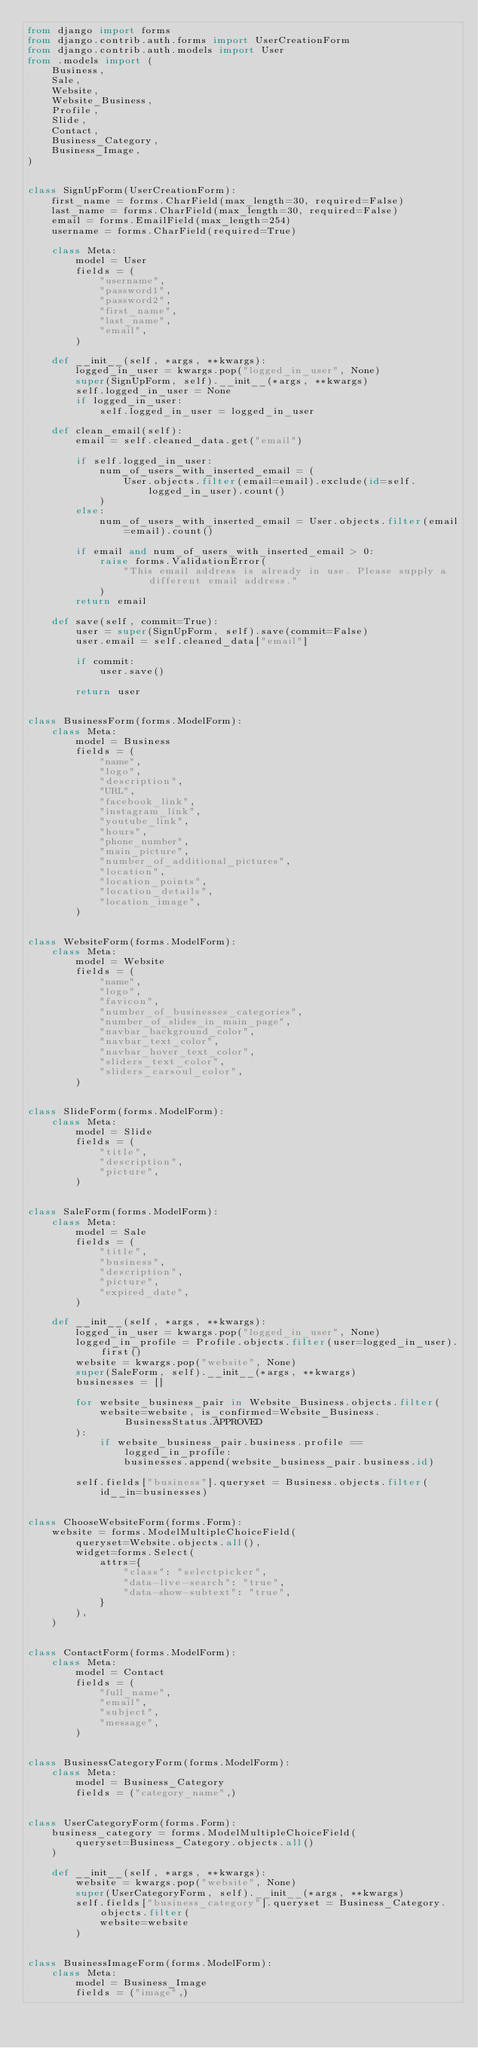<code> <loc_0><loc_0><loc_500><loc_500><_Python_>from django import forms
from django.contrib.auth.forms import UserCreationForm
from django.contrib.auth.models import User
from .models import (
    Business,
    Sale,
    Website,
    Website_Business,
    Profile,
    Slide,
    Contact,
    Business_Category,
    Business_Image,
)


class SignUpForm(UserCreationForm):
    first_name = forms.CharField(max_length=30, required=False)
    last_name = forms.CharField(max_length=30, required=False)
    email = forms.EmailField(max_length=254)
    username = forms.CharField(required=True)

    class Meta:
        model = User
        fields = (
            "username",
            "password1",
            "password2",
            "first_name",
            "last_name",
            "email",
        )

    def __init__(self, *args, **kwargs):
        logged_in_user = kwargs.pop("logged_in_user", None)
        super(SignUpForm, self).__init__(*args, **kwargs)
        self.logged_in_user = None
        if logged_in_user:
            self.logged_in_user = logged_in_user

    def clean_email(self):
        email = self.cleaned_data.get("email")

        if self.logged_in_user:
            num_of_users_with_inserted_email = (
                User.objects.filter(email=email).exclude(id=self.logged_in_user).count()
            )
        else:
            num_of_users_with_inserted_email = User.objects.filter(email=email).count()

        if email and num_of_users_with_inserted_email > 0:
            raise forms.ValidationError(
                "This email address is already in use. Please supply a different email address."
            )
        return email

    def save(self, commit=True):
        user = super(SignUpForm, self).save(commit=False)
        user.email = self.cleaned_data["email"]

        if commit:
            user.save()

        return user


class BusinessForm(forms.ModelForm):
    class Meta:
        model = Business
        fields = (
            "name",
            "logo",
            "description",
            "URL",
            "facebook_link",
            "instagram_link",
            "youtube_link",
            "hours",
            "phone_number",
            "main_picture",
            "number_of_additional_pictures",
            "location",
            "location_points",
            "location_details",
            "location_image",
        )


class WebsiteForm(forms.ModelForm):
    class Meta:
        model = Website
        fields = (
            "name",
            "logo",
            "favicon",
            "number_of_businesses_categories",
            "number_of_slides_in_main_page",
            "navbar_background_color",
            "navbar_text_color",
            "navbar_hover_text_color",
            "sliders_text_color",
            "sliders_carsoul_color",
        )


class SlideForm(forms.ModelForm):
    class Meta:
        model = Slide
        fields = (
            "title",
            "description",
            "picture",
        )


class SaleForm(forms.ModelForm):
    class Meta:
        model = Sale
        fields = (
            "title",
            "business",
            "description",
            "picture",
            "expired_date",
        )

    def __init__(self, *args, **kwargs):
        logged_in_user = kwargs.pop("logged_in_user", None)
        logged_in_profile = Profile.objects.filter(user=logged_in_user).first()
        website = kwargs.pop("website", None)
        super(SaleForm, self).__init__(*args, **kwargs)
        businesses = []

        for website_business_pair in Website_Business.objects.filter(
            website=website, is_confirmed=Website_Business.BusinessStatus.APPROVED
        ):
            if website_business_pair.business.profile == logged_in_profile:
                businesses.append(website_business_pair.business.id)

        self.fields["business"].queryset = Business.objects.filter(id__in=businesses)


class ChooseWebsiteForm(forms.Form):
    website = forms.ModelMultipleChoiceField(
        queryset=Website.objects.all(),
        widget=forms.Select(
            attrs={
                "class": "selectpicker",
                "data-live-search": "true",
                "data-show-subtext": "true",
            }
        ),
    )


class ContactForm(forms.ModelForm):
    class Meta:
        model = Contact
        fields = (
            "full_name",
            "email",
            "subject",
            "message",
        )


class BusinessCategoryForm(forms.ModelForm):
    class Meta:
        model = Business_Category
        fields = ("category_name",)


class UserCategoryForm(forms.Form):
    business_category = forms.ModelMultipleChoiceField(
        queryset=Business_Category.objects.all()
    )

    def __init__(self, *args, **kwargs):
        website = kwargs.pop("website", None)
        super(UserCategoryForm, self).__init__(*args, **kwargs)
        self.fields["business_category"].queryset = Business_Category.objects.filter(
            website=website
        )


class BusinessImageForm(forms.ModelForm):
    class Meta:
        model = Business_Image
        fields = ("image",)
</code> 